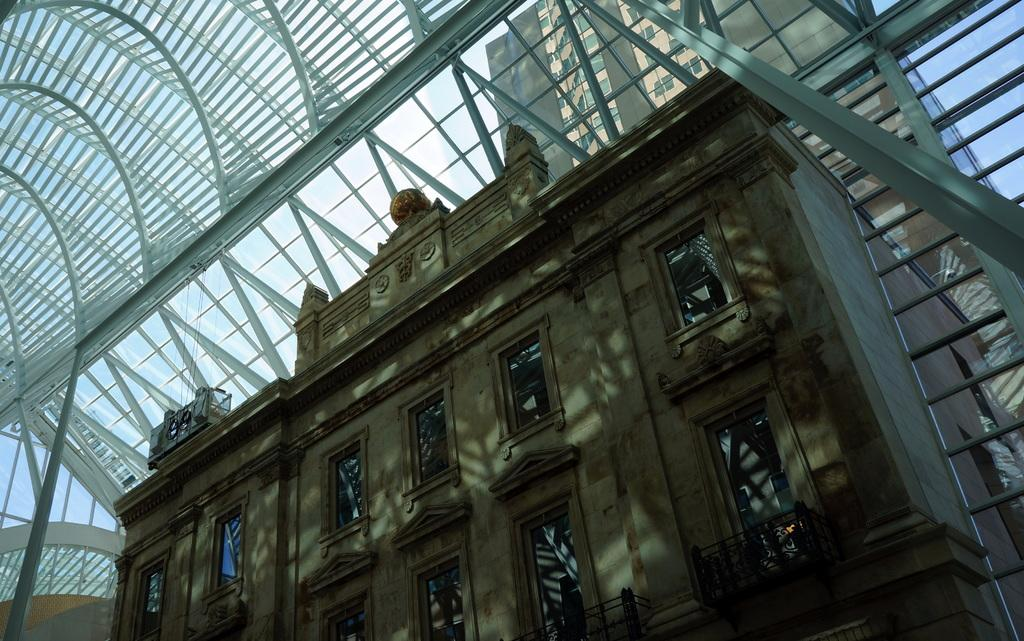What type of structure is present in the image? There is a building in the image. What feature does the building have? The building has a glass roof. What does the glass roof allow for? The glass roof allows for a view of other buildings. What can be seen through the glass roof? The sky is visible through the glass roof. What type of caption is written on the building in the image? There is no caption written on the building in the image. How does the rainstorm affect the view of other buildings through the glass roof? There is no rainstorm present in the image, so its effect on the view cannot be determined. 